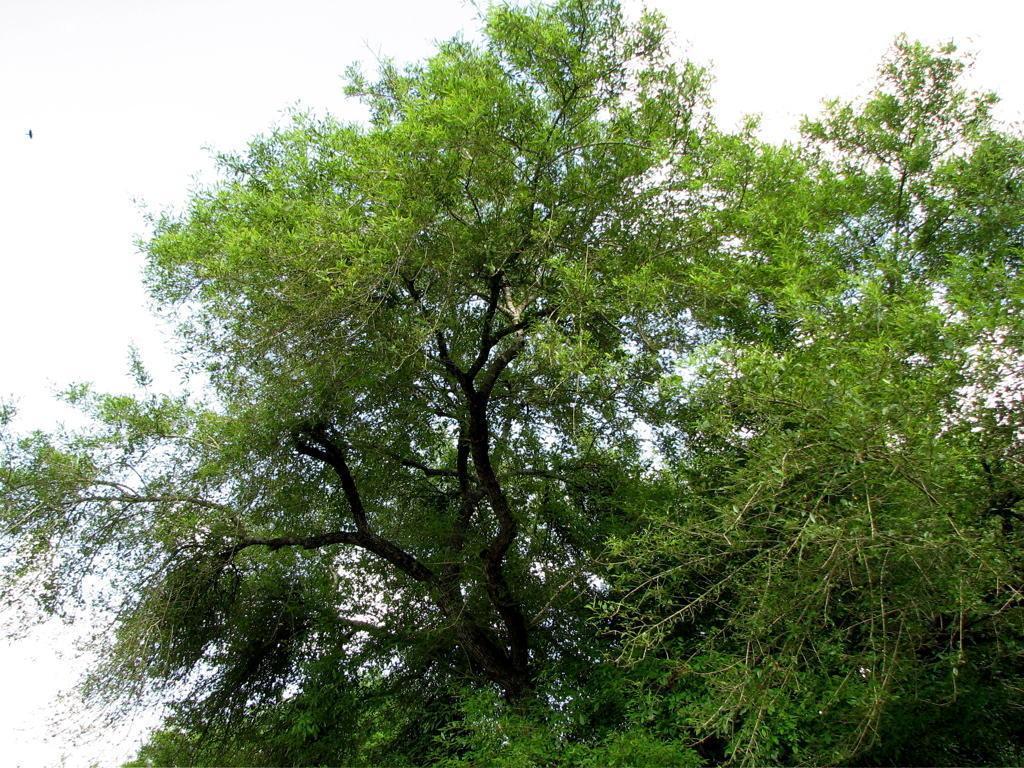How would you summarize this image in a sentence or two? In this picture we can see the sky and a tree. 